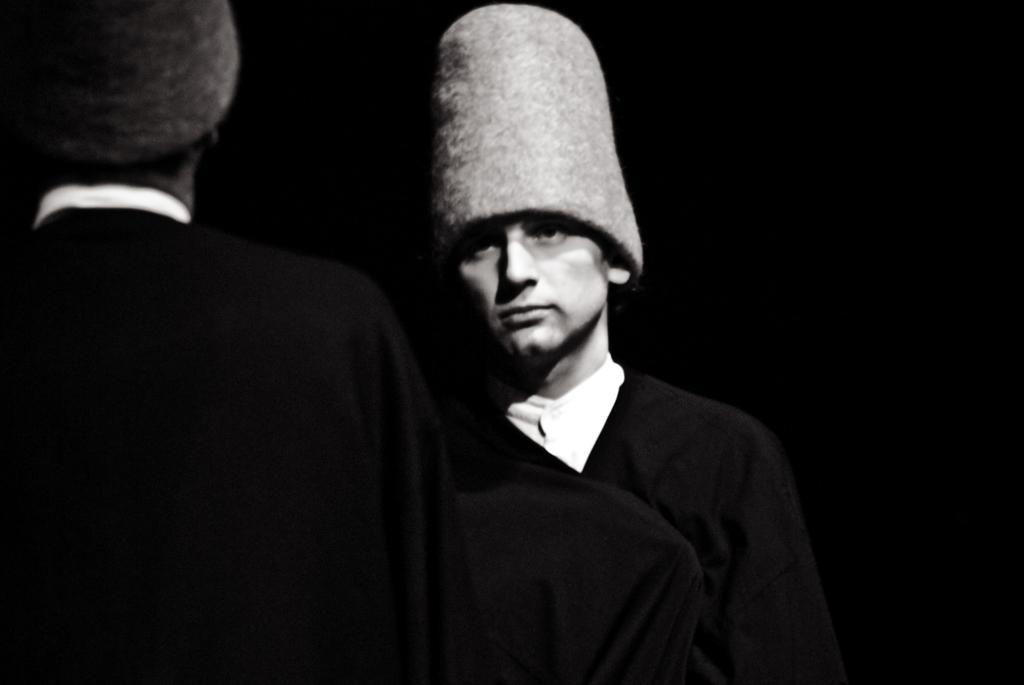What is the color scheme of the image? The image is black and white. How many people are in the image? There are two persons in the image. What are the people wearing on their heads? Both persons are wearing caps. What can be observed about the background of the image? The background of the image is dark. What type of train can be seen in the background of the image? There is no train present in the image; it is a black and white image of two persons wearing caps with a dark background. Can you tell me how many drawers are visible in the image? There are no drawers present in the image. 